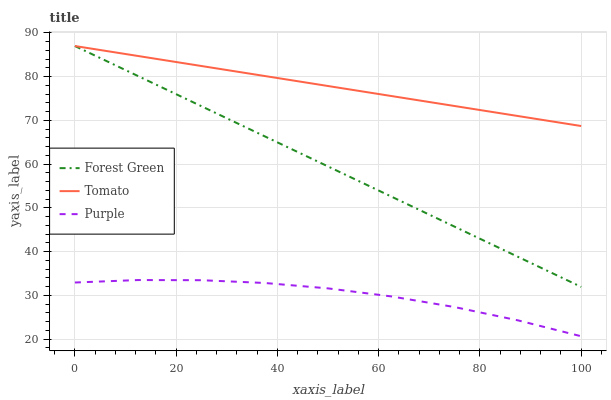Does Forest Green have the minimum area under the curve?
Answer yes or no. No. Does Forest Green have the maximum area under the curve?
Answer yes or no. No. Is Forest Green the smoothest?
Answer yes or no. No. Is Forest Green the roughest?
Answer yes or no. No. Does Forest Green have the lowest value?
Answer yes or no. No. Does Purple have the highest value?
Answer yes or no. No. Is Purple less than Forest Green?
Answer yes or no. Yes. Is Tomato greater than Purple?
Answer yes or no. Yes. Does Purple intersect Forest Green?
Answer yes or no. No. 